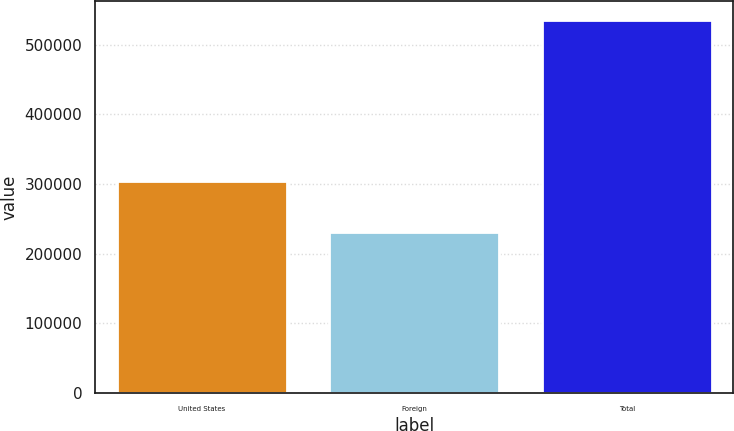Convert chart to OTSL. <chart><loc_0><loc_0><loc_500><loc_500><bar_chart><fcel>United States<fcel>Foreign<fcel>Total<nl><fcel>304743<fcel>231261<fcel>536004<nl></chart> 